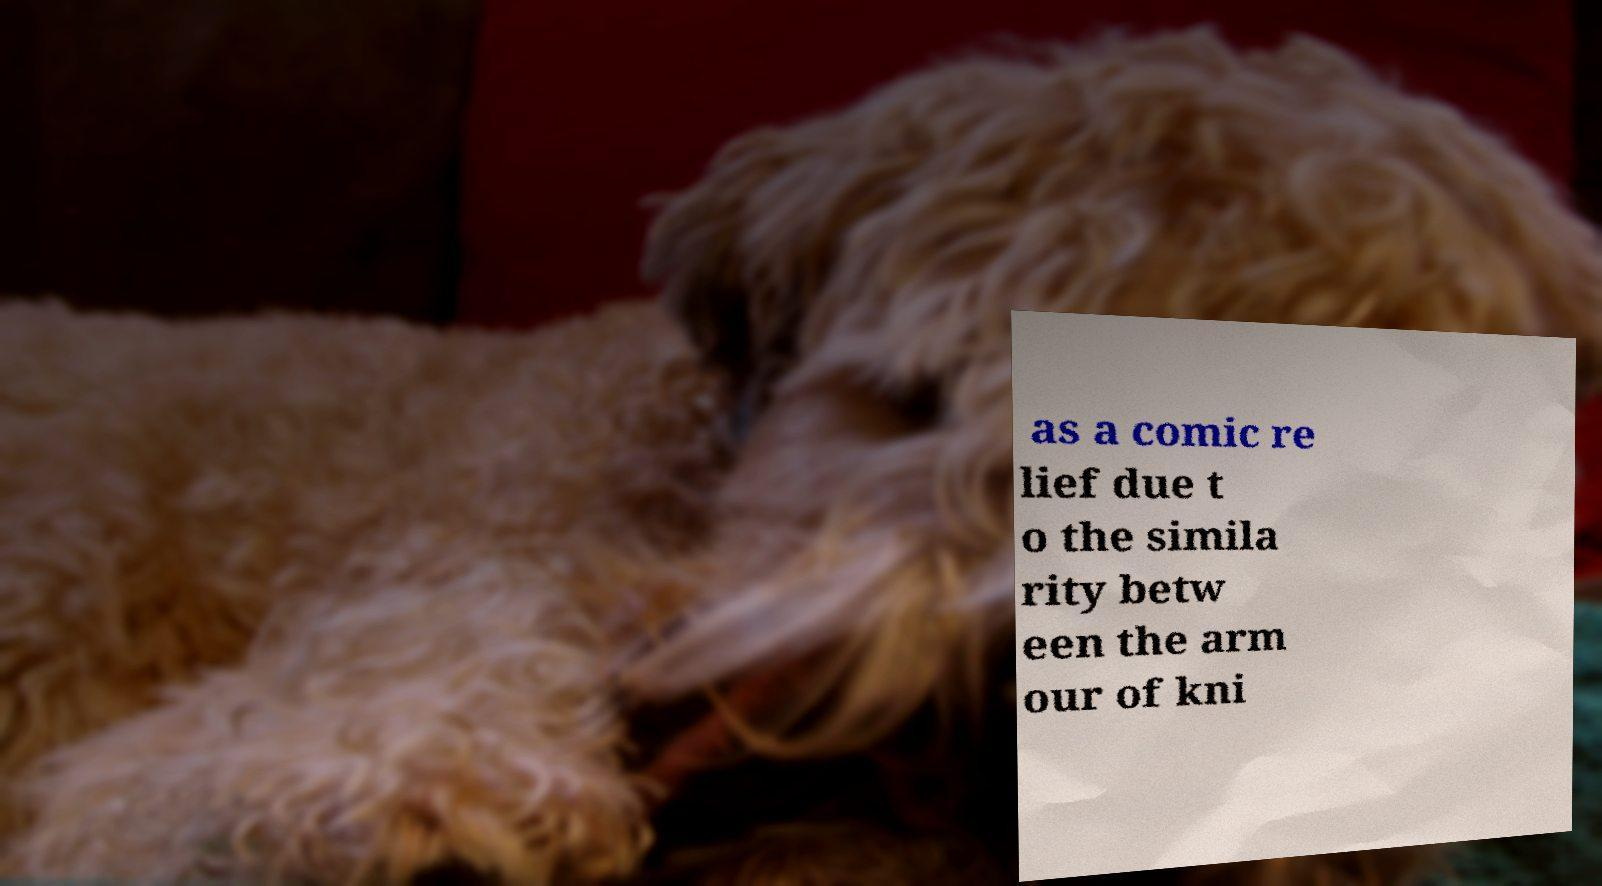For documentation purposes, I need the text within this image transcribed. Could you provide that? as a comic re lief due t o the simila rity betw een the arm our of kni 